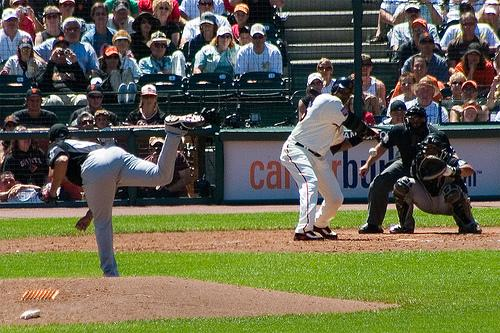What is the sponsor's industry? unknown 